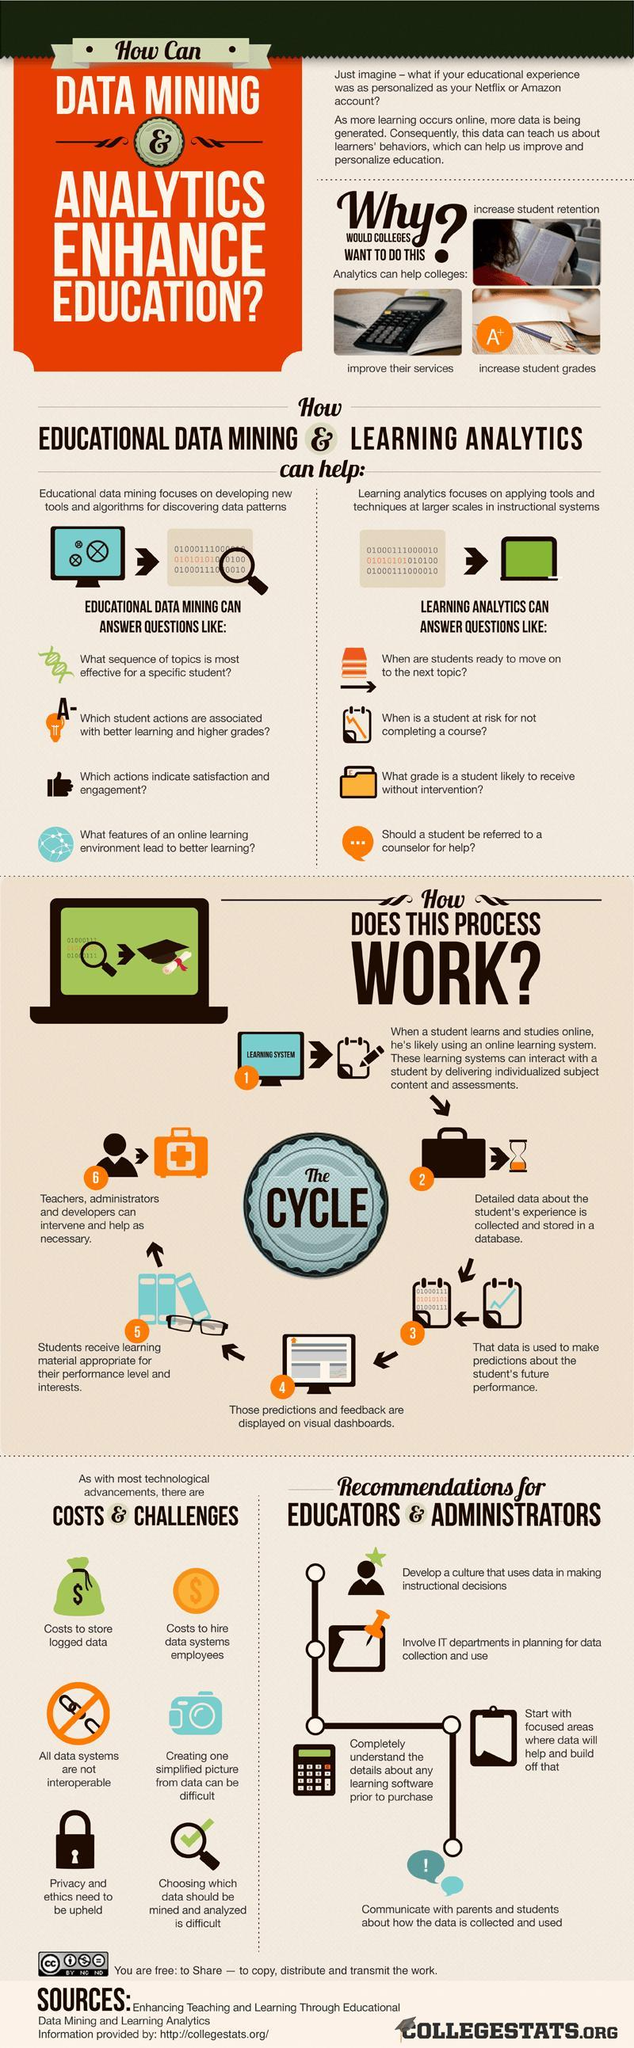How many recommendations are given for educators and administrators?
Answer the question with a short phrase. 4 What is written on the screen of the computer? Learning system What does colleges want to increase with the help of analytics? student retention, student grades 